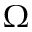<formula> <loc_0><loc_0><loc_500><loc_500>\Omega</formula> 